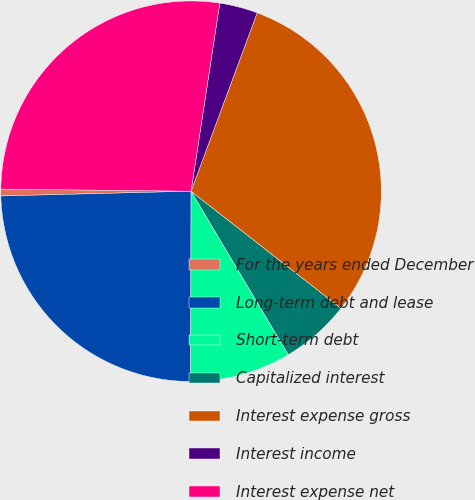Convert chart to OTSL. <chart><loc_0><loc_0><loc_500><loc_500><pie_chart><fcel>For the years ended December<fcel>Long-term debt and lease<fcel>Short-term debt<fcel>Capitalized interest<fcel>Interest expense gross<fcel>Interest income<fcel>Interest expense net<nl><fcel>0.58%<fcel>24.57%<fcel>8.57%<fcel>5.91%<fcel>29.9%<fcel>3.24%<fcel>27.23%<nl></chart> 